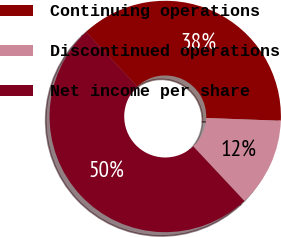Convert chart to OTSL. <chart><loc_0><loc_0><loc_500><loc_500><pie_chart><fcel>Continuing operations<fcel>Discontinued operations<fcel>Net income per share<nl><fcel>37.57%<fcel>12.43%<fcel>50.0%<nl></chart> 